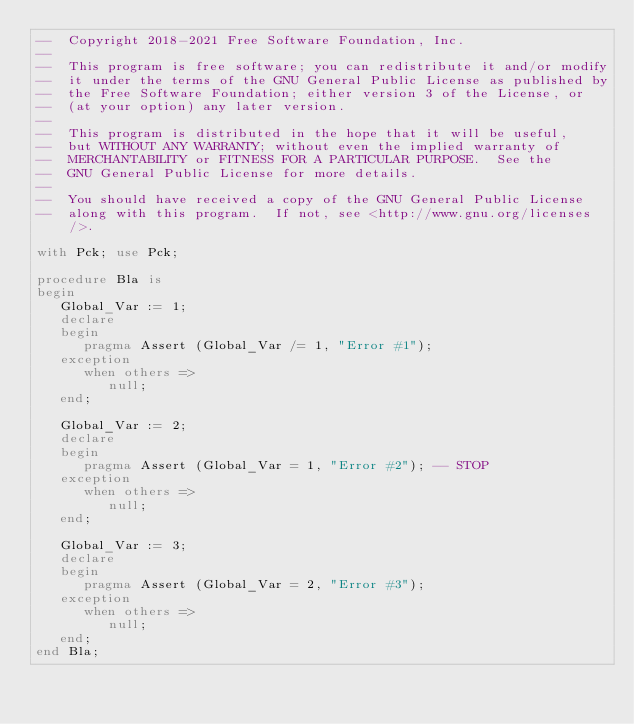Convert code to text. <code><loc_0><loc_0><loc_500><loc_500><_Ada_>--  Copyright 2018-2021 Free Software Foundation, Inc.
--
--  This program is free software; you can redistribute it and/or modify
--  it under the terms of the GNU General Public License as published by
--  the Free Software Foundation; either version 3 of the License, or
--  (at your option) any later version.
--
--  This program is distributed in the hope that it will be useful,
--  but WITHOUT ANY WARRANTY; without even the implied warranty of
--  MERCHANTABILITY or FITNESS FOR A PARTICULAR PURPOSE.  See the
--  GNU General Public License for more details.
--
--  You should have received a copy of the GNU General Public License
--  along with this program.  If not, see <http://www.gnu.org/licenses/>.

with Pck; use Pck;

procedure Bla is
begin
   Global_Var := 1;
   declare
   begin
      pragma Assert (Global_Var /= 1, "Error #1");
   exception
      when others =>
         null;
   end;

   Global_Var := 2;
   declare
   begin
      pragma Assert (Global_Var = 1, "Error #2"); -- STOP
   exception
      when others =>
         null;
   end;

   Global_Var := 3;
   declare
   begin
      pragma Assert (Global_Var = 2, "Error #3");
   exception
      when others =>
         null;
   end;
end Bla;
</code> 